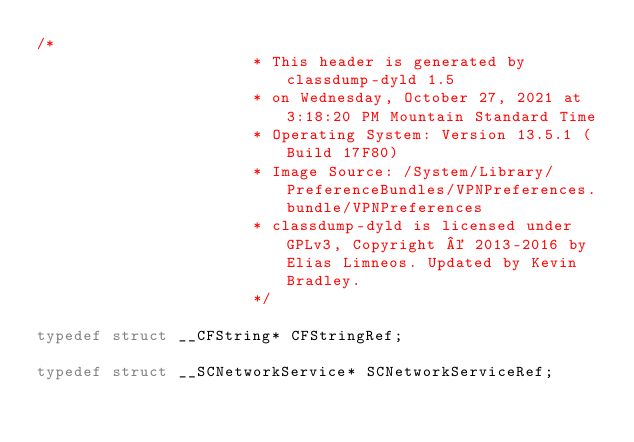Convert code to text. <code><loc_0><loc_0><loc_500><loc_500><_C_>/*
                       * This header is generated by classdump-dyld 1.5
                       * on Wednesday, October 27, 2021 at 3:18:20 PM Mountain Standard Time
                       * Operating System: Version 13.5.1 (Build 17F80)
                       * Image Source: /System/Library/PreferenceBundles/VPNPreferences.bundle/VPNPreferences
                       * classdump-dyld is licensed under GPLv3, Copyright © 2013-2016 by Elias Limneos. Updated by Kevin Bradley.
                       */

typedef struct __CFString* CFStringRef;

typedef struct __SCNetworkService* SCNetworkServiceRef;

</code> 